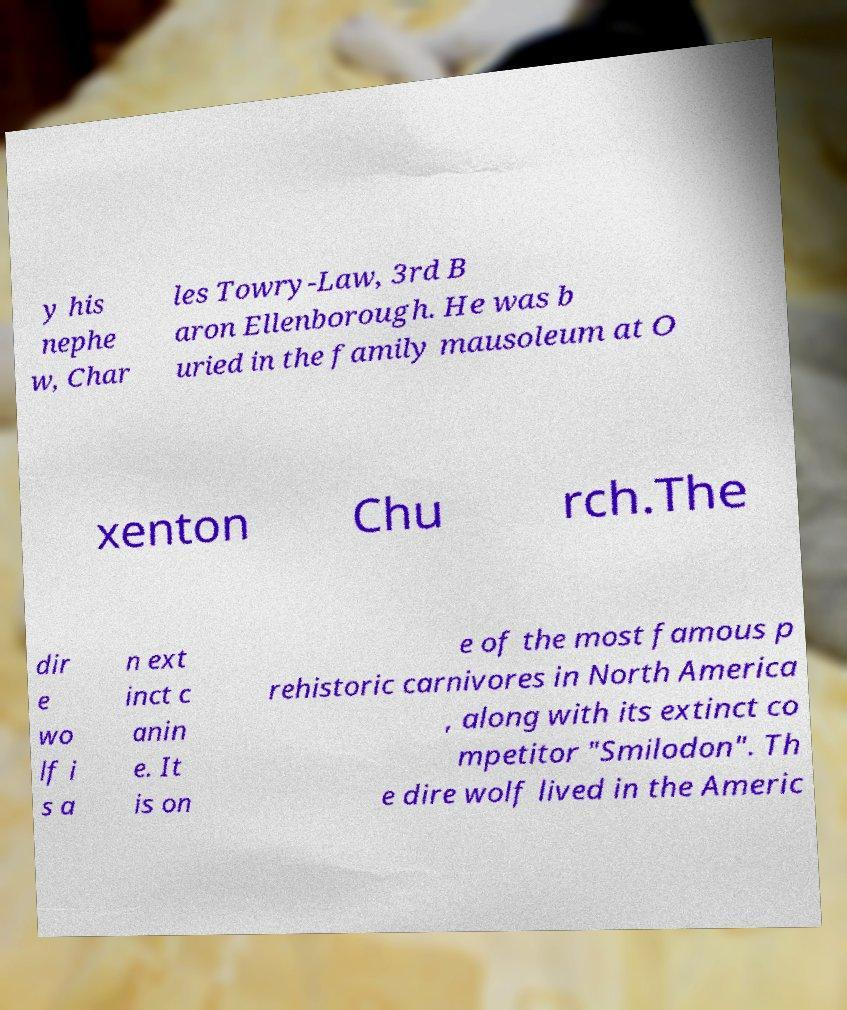What messages or text are displayed in this image? I need them in a readable, typed format. y his nephe w, Char les Towry-Law, 3rd B aron Ellenborough. He was b uried in the family mausoleum at O xenton Chu rch.The dir e wo lf i s a n ext inct c anin e. It is on e of the most famous p rehistoric carnivores in North America , along with its extinct co mpetitor "Smilodon". Th e dire wolf lived in the Americ 